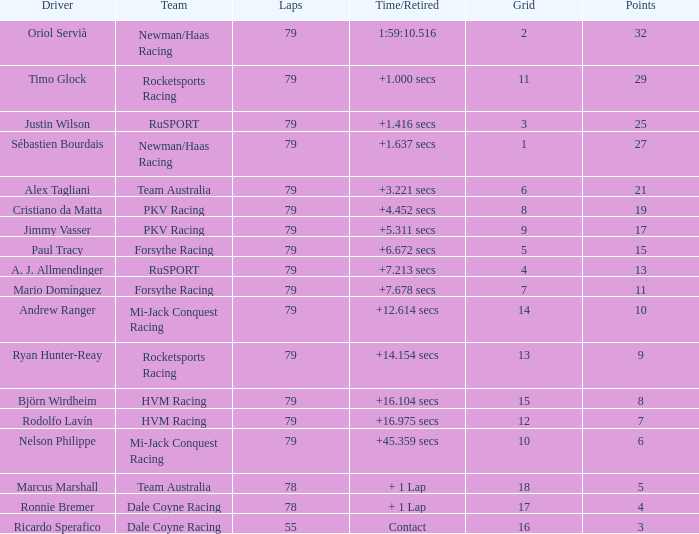In what 78-lap racing grid does ronnie bremer serve as the driver? 17.0. 